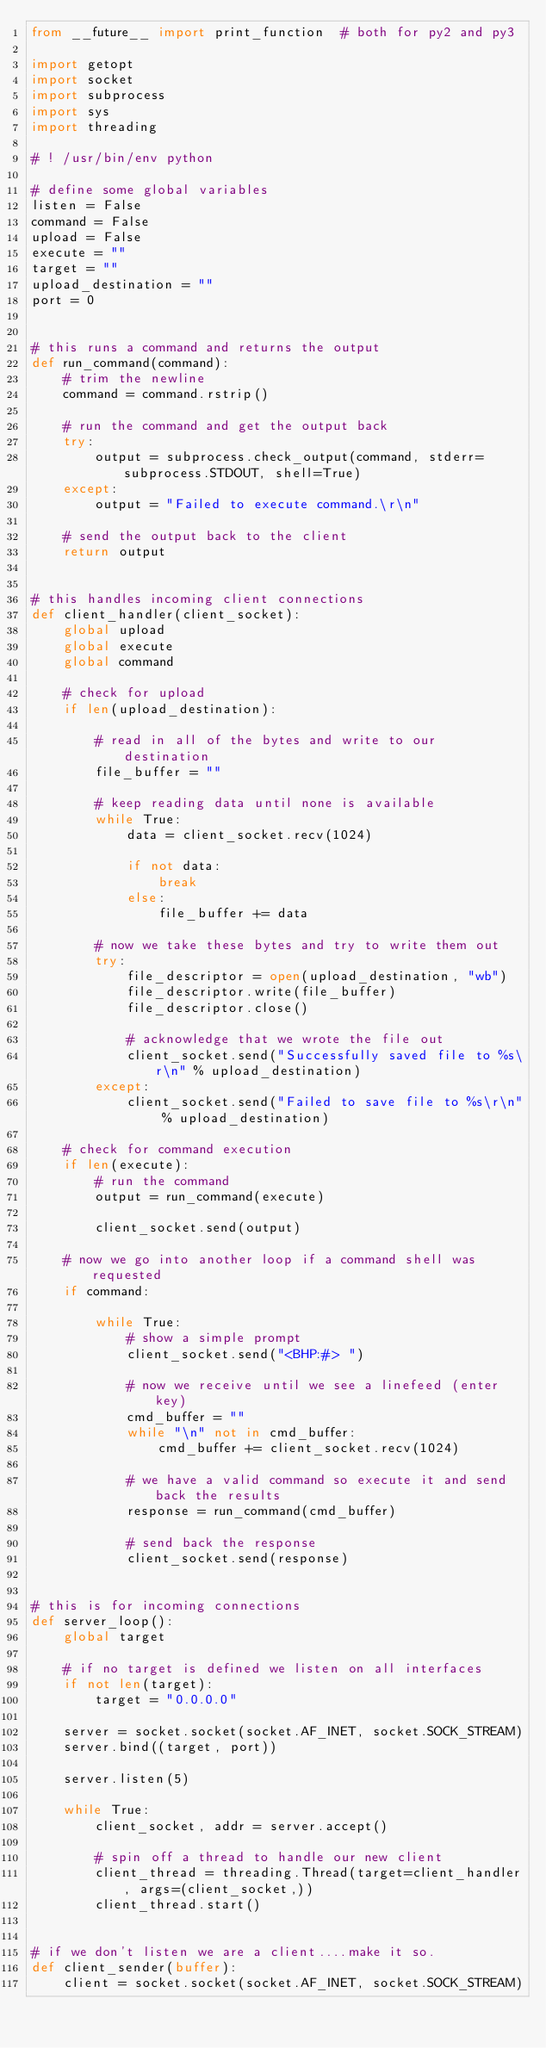<code> <loc_0><loc_0><loc_500><loc_500><_Python_>from __future__ import print_function  # both for py2 and py3

import getopt
import socket
import subprocess
import sys
import threading

# ! /usr/bin/env python

# define some global variables
listen = False
command = False
upload = False
execute = ""
target = ""
upload_destination = ""
port = 0


# this runs a command and returns the output
def run_command(command):
    # trim the newline
    command = command.rstrip()

    # run the command and get the output back
    try:
        output = subprocess.check_output(command, stderr=subprocess.STDOUT, shell=True)
    except:
        output = "Failed to execute command.\r\n"

    # send the output back to the client
    return output


# this handles incoming client connections
def client_handler(client_socket):
    global upload
    global execute
    global command

    # check for upload
    if len(upload_destination):

        # read in all of the bytes and write to our destination
        file_buffer = ""

        # keep reading data until none is available
        while True:
            data = client_socket.recv(1024)

            if not data:
                break
            else:
                file_buffer += data

        # now we take these bytes and try to write them out
        try:
            file_descriptor = open(upload_destination, "wb")
            file_descriptor.write(file_buffer)
            file_descriptor.close()

            # acknowledge that we wrote the file out
            client_socket.send("Successfully saved file to %s\r\n" % upload_destination)
        except:
            client_socket.send("Failed to save file to %s\r\n" % upload_destination)

    # check for command execution
    if len(execute):
        # run the command
        output = run_command(execute)

        client_socket.send(output)

    # now we go into another loop if a command shell was requested
    if command:

        while True:
            # show a simple prompt
            client_socket.send("<BHP:#> ")

            # now we receive until we see a linefeed (enter key)
            cmd_buffer = ""
            while "\n" not in cmd_buffer:
                cmd_buffer += client_socket.recv(1024)

            # we have a valid command so execute it and send back the results
            response = run_command(cmd_buffer)

            # send back the response
            client_socket.send(response)


# this is for incoming connections
def server_loop():
    global target

    # if no target is defined we listen on all interfaces
    if not len(target):
        target = "0.0.0.0"

    server = socket.socket(socket.AF_INET, socket.SOCK_STREAM)
    server.bind((target, port))

    server.listen(5)

    while True:
        client_socket, addr = server.accept()

        # spin off a thread to handle our new client
        client_thread = threading.Thread(target=client_handler, args=(client_socket,))
        client_thread.start()


# if we don't listen we are a client....make it so.
def client_sender(buffer):
    client = socket.socket(socket.AF_INET, socket.SOCK_STREAM)
</code> 